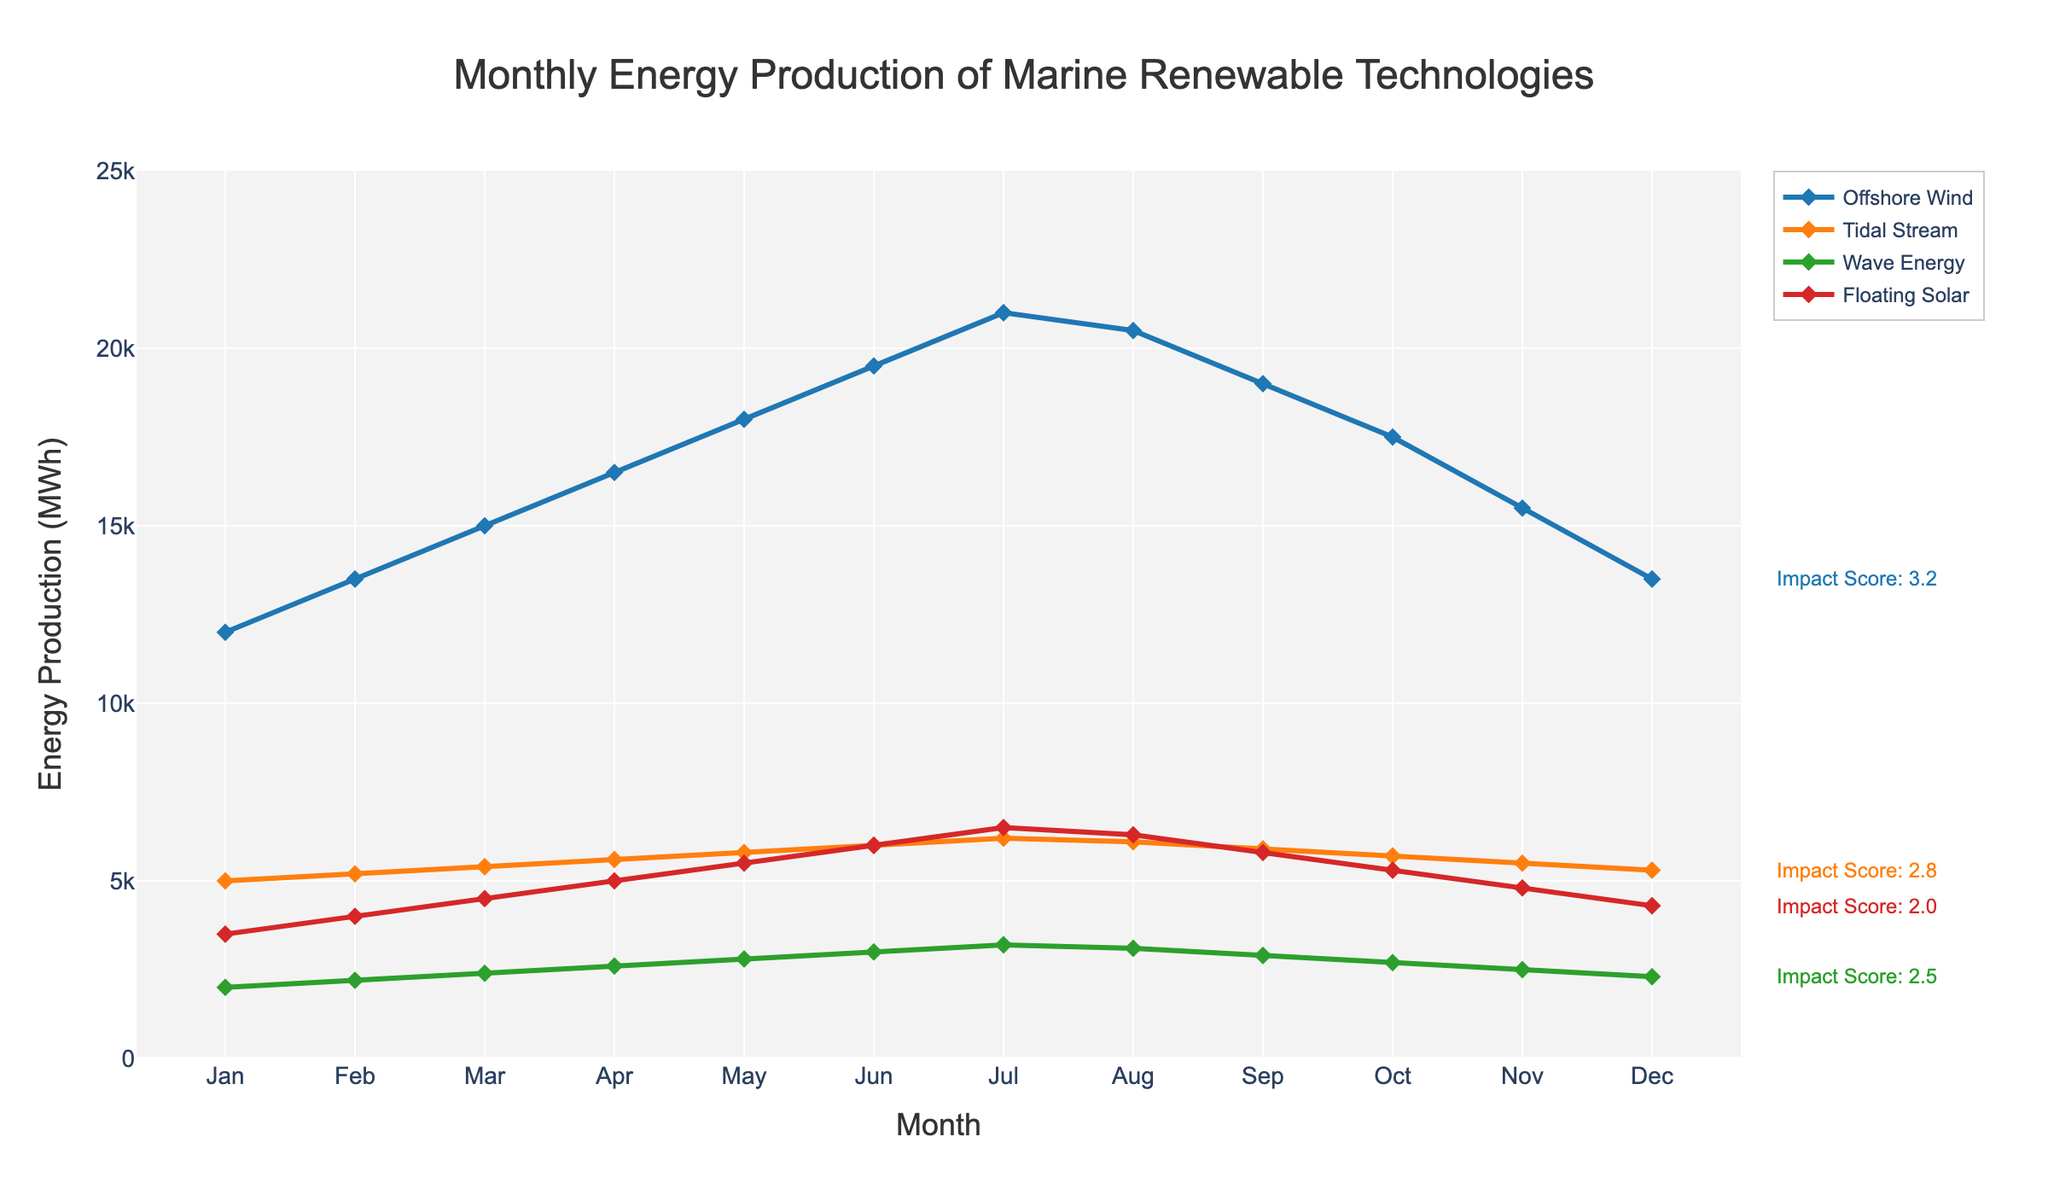What's the trend in energy production for Offshore Wind throughout the year? To determine the trend, examine the line chart for Offshore Wind. The production starts at 12,000 MWh in January and rises steadily each month, peaking in July at 21,000 MWh. Then, it gradually declines, ending at 13,500 MWh in December.
Answer: Increasing in the first half of the year, then decreasing in the second half Which technology has the lowest environmental impact score and what is this score? The plot's annotations for environmental impact scores next to each technology show that Floating Solar has the lowest score of 2.0.
Answer: Floating Solar, 2.0 What is the difference in energy production between Offshore Wind and Wave Energy in July? Offshore Wind produces 21,000 MWh in July and Wave Energy produces 3,200 MWh. The difference is calculated as 21,000 - 3,200.
Answer: 17,800 MWh Which month had the highest energy production for Tidal Stream and what was the production? Checking the line for Tidal Stream, June shows the highest production at 6,200 MWh.
Answer: June, 6,200 MWh Compare the energy production of Floating Solar and Tidal Stream in September, which one is higher and by how much? In September, Floating Solar produces 5,800 MWh while Tidal Stream produces 5,900 MWh. The difference is 5,900 - 5,800 MWh.
Answer: Tidal Stream by 100 MWh During which months is Wave Energy's production between 2,000 and 3,000 MWh? Observing the Wave Energy line, it is between this range from January to May and September to December.
Answer: January to May, September to December What is the average monthly energy production for Tidal Stream? Sum the monthly productions for Tidal Stream and divide by 12. (5,000 + 5,200 + 5,400 + 5,600 + 5,800 + 6,000 + 6,200 + 6,100 + 5,900 + 5,700 + 5,500 + 5,300) / 12 = 5,691.7 MWh.
Answer: 5,691.7 MWh By how much does Offshore Wind production exceed Tidal Stream production in February? Offshore Wind produces 13,500 MWh in February, while Tidal Stream produces 5,200 MWh. The difference is 13,500 - 5,200 MWh.
Answer: 8,300 MWh 